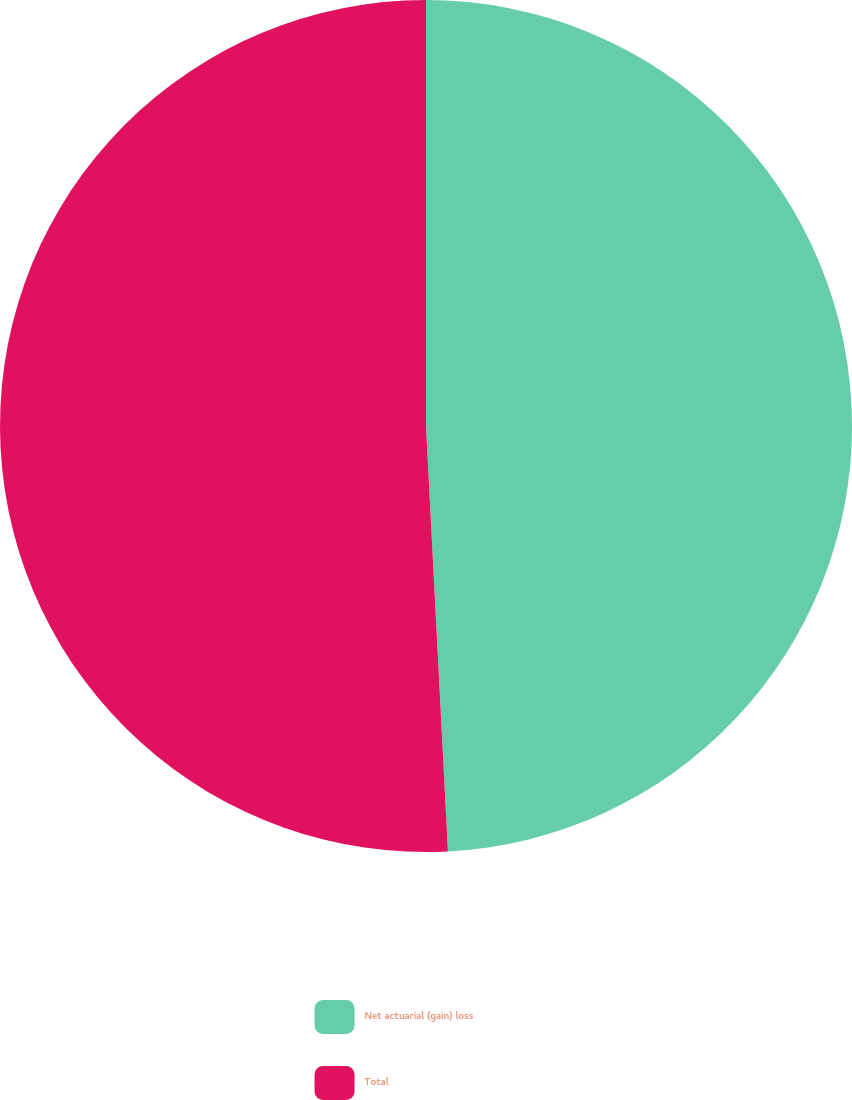<chart> <loc_0><loc_0><loc_500><loc_500><pie_chart><fcel>Net actuarial (gain) loss<fcel>Total<nl><fcel>49.18%<fcel>50.82%<nl></chart> 